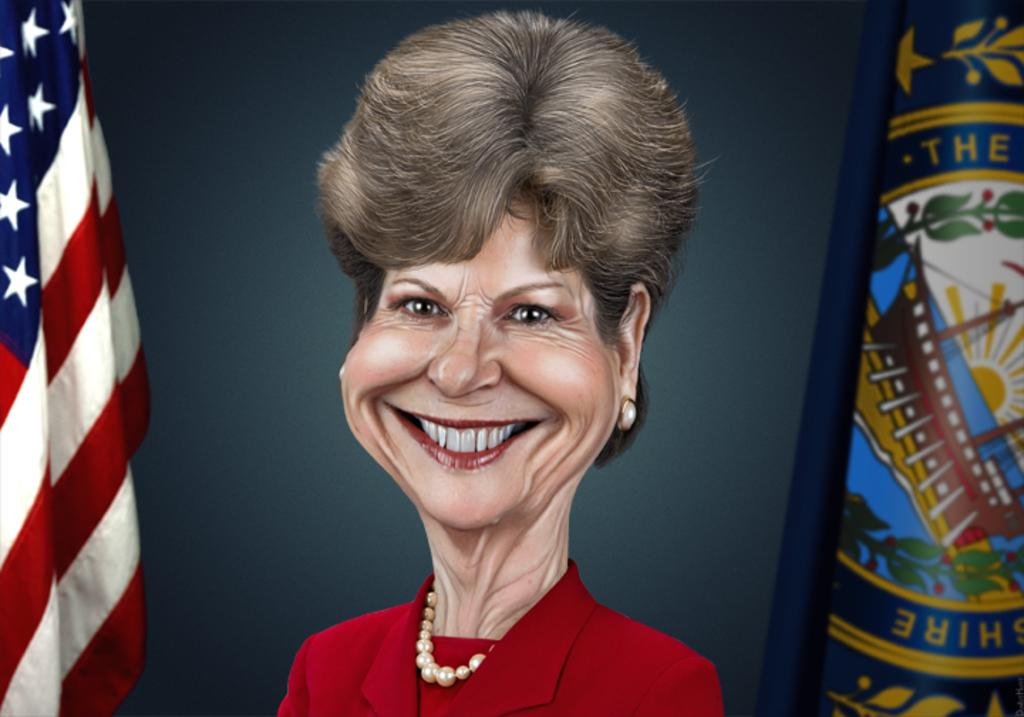What is depicted in the image? There is an art of a person in the image. What else can be seen in the image? There is a flag in the image. Can you describe the object on the right side of the image? Unfortunately, the provided facts do not give enough information to describe the object on the right side of the image. How many ducks are visible on the slope in the image? There is no slope or duck present in the image. 